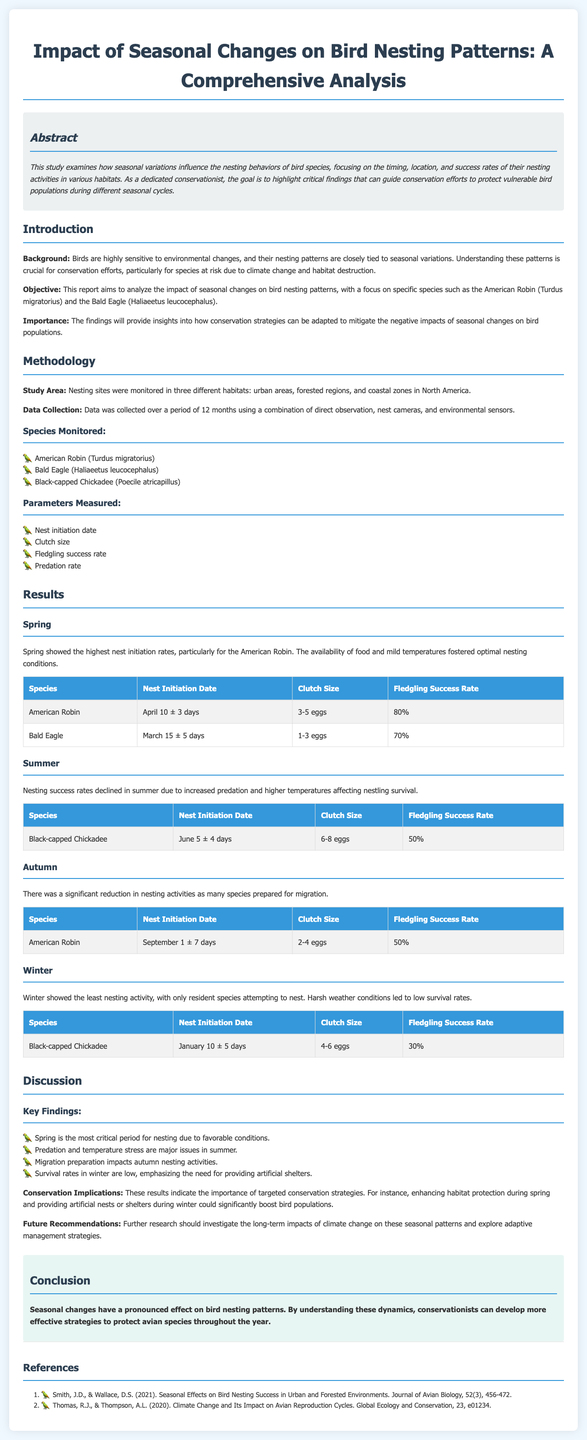what is the title of the lab report? The title is presented at the top of the document, indicating the subject of study.
Answer: Impact of Seasonal Changes on Bird Nesting Patterns: A Comprehensive Analysis which bird species had the highest fledgling success rate in spring? The report provides specific data about nesting success rates for different bird species during spring.
Answer: American Robin what is the nest initiation date for Bald Eagles? This information can be found in the results section under the spring and summer categories.
Answer: March 15 ± 5 days what are the parameters measured in the study? The document lists specific metrics regarding nesting activities monitored in various bird species.
Answer: Nest initiation date, Clutch size, Fledgling success rate, Predation rate which season showed the least nesting activity? The document discusses nesting activities across different seasons and identifies the least active one.
Answer: Winter what conservation implication is highlighted in the discussion? The document emphasizes an important strategy for conservation based on the findings.
Answer: Providing artificial shelters how did summer conditions affect nesting success rates? The discussion links specific environmental issues in summer to their effects on bird nesting.
Answer: Increased predation and higher temperatures what is the study area for the research? The report mentions the specific locations where the data was collected regarding bird nesting.
Answer: Urban areas, forested regions, and coastal zones in North America what type of data collection methods were used in this study? The methodology section outlines the techniques employed for gathering data throughout the study.
Answer: Direct observation, nest cameras, and environmental sensors 